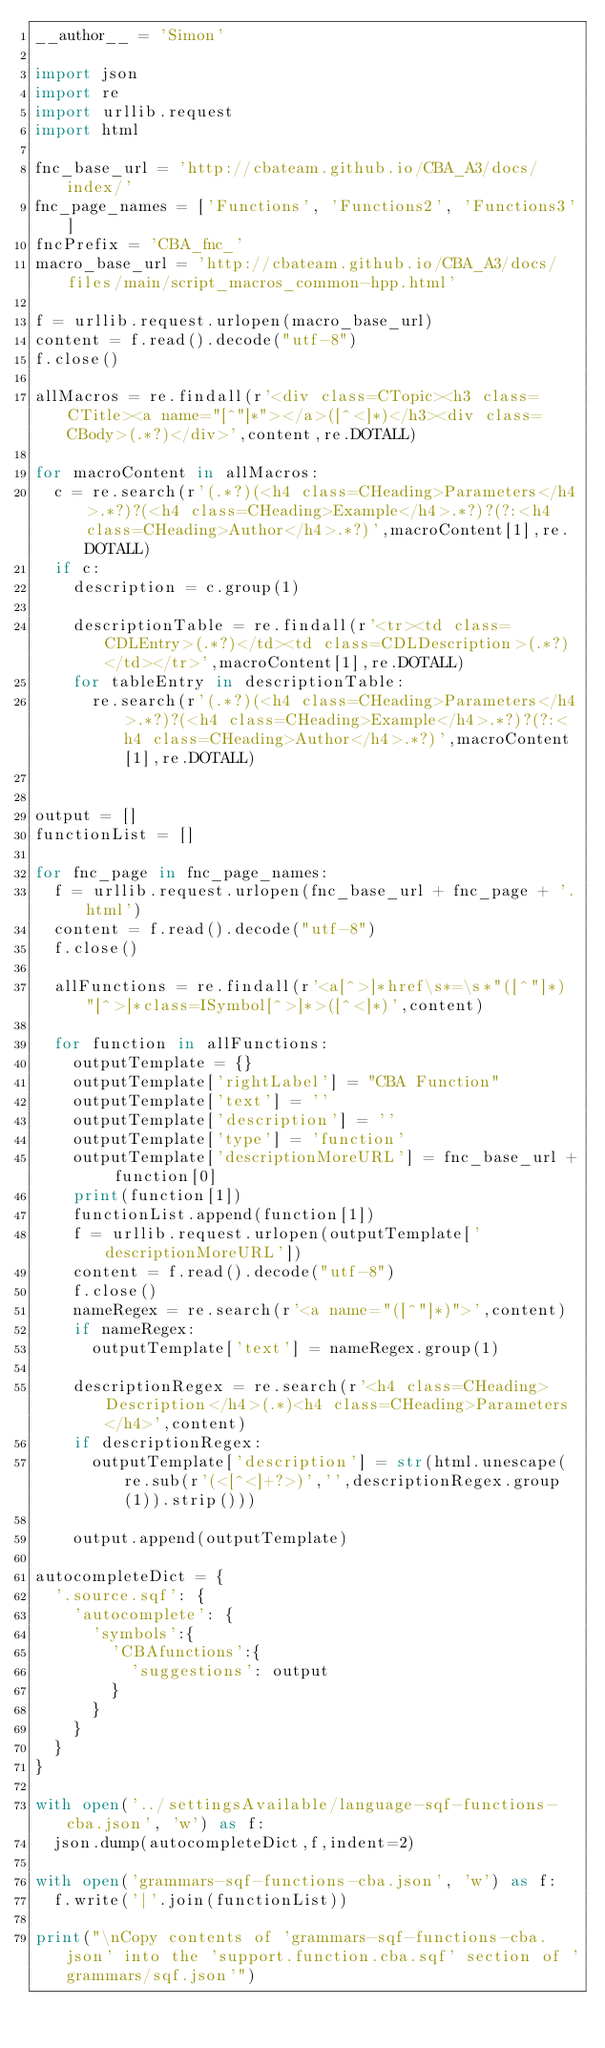Convert code to text. <code><loc_0><loc_0><loc_500><loc_500><_Python_>__author__ = 'Simon'

import json
import re
import urllib.request
import html

fnc_base_url = 'http://cbateam.github.io/CBA_A3/docs/index/'
fnc_page_names = ['Functions', 'Functions2', 'Functions3']
fncPrefix = 'CBA_fnc_'
macro_base_url = 'http://cbateam.github.io/CBA_A3/docs/files/main/script_macros_common-hpp.html'

f = urllib.request.urlopen(macro_base_url)
content = f.read().decode("utf-8")
f.close()

allMacros = re.findall(r'<div class=CTopic><h3 class=CTitle><a name="[^"]*"></a>([^<]*)</h3><div class=CBody>(.*?)</div>',content,re.DOTALL)

for macroContent in allMacros:
  c = re.search(r'(.*?)(<h4 class=CHeading>Parameters</h4>.*?)?(<h4 class=CHeading>Example</h4>.*?)?(?:<h4 class=CHeading>Author</h4>.*?)',macroContent[1],re.DOTALL)
  if c:
    description = c.group(1)

    descriptionTable = re.findall(r'<tr><td class=CDLEntry>(.*?)</td><td class=CDLDescription>(.*?)</td></tr>',macroContent[1],re.DOTALL)
    for tableEntry in descriptionTable:
      re.search(r'(.*?)(<h4 class=CHeading>Parameters</h4>.*?)?(<h4 class=CHeading>Example</h4>.*?)?(?:<h4 class=CHeading>Author</h4>.*?)',macroContent[1],re.DOTALL)


output = []
functionList = []

for fnc_page in fnc_page_names:
  f = urllib.request.urlopen(fnc_base_url + fnc_page + '.html')
  content = f.read().decode("utf-8")
  f.close()

  allFunctions = re.findall(r'<a[^>]*href\s*=\s*"([^"]*)"[^>]*class=ISymbol[^>]*>([^<]*)',content)

  for function in allFunctions:
    outputTemplate = {}
    outputTemplate['rightLabel'] = "CBA Function"
    outputTemplate['text'] = ''
    outputTemplate['description'] = ''
    outputTemplate['type'] = 'function'
    outputTemplate['descriptionMoreURL'] = fnc_base_url + function[0]
    print(function[1])
    functionList.append(function[1])
    f = urllib.request.urlopen(outputTemplate['descriptionMoreURL'])
    content = f.read().decode("utf-8")
    f.close()
    nameRegex = re.search(r'<a name="([^"]*)">',content)
    if nameRegex:
      outputTemplate['text'] = nameRegex.group(1)

    descriptionRegex = re.search(r'<h4 class=CHeading>Description</h4>(.*)<h4 class=CHeading>Parameters</h4>',content)
    if descriptionRegex:
      outputTemplate['description'] = str(html.unescape(re.sub(r'(<[^<]+?>)','',descriptionRegex.group(1)).strip()))

    output.append(outputTemplate)

autocompleteDict = {
  '.source.sqf': {
    'autocomplete': {
      'symbols':{
        'CBAfunctions':{
          'suggestions': output
        }
      }
    }
  }
}

with open('../settingsAvailable/language-sqf-functions-cba.json', 'w') as f:
  json.dump(autocompleteDict,f,indent=2)

with open('grammars-sqf-functions-cba.json', 'w') as f:
  f.write('|'.join(functionList))

print("\nCopy contents of 'grammars-sqf-functions-cba.json' into the 'support.function.cba.sqf' section of 'grammars/sqf.json'")
</code> 